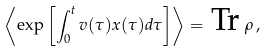Convert formula to latex. <formula><loc_0><loc_0><loc_500><loc_500>\left \langle \exp \left [ \int _ { 0 } ^ { t } v ( \tau ) x ( \tau ) d \tau \right ] \right \rangle = \, \text {Tr\,} \rho \, ,</formula> 